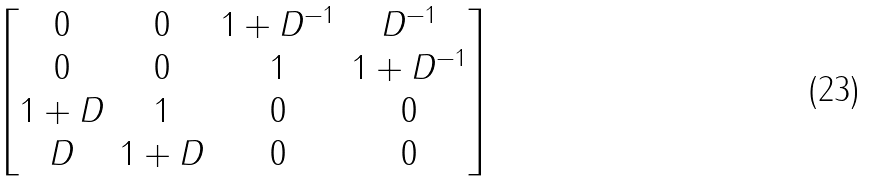<formula> <loc_0><loc_0><loc_500><loc_500>\begin{bmatrix} 0 & 0 & 1 + D ^ { - 1 } & D ^ { - 1 } \\ 0 & 0 & 1 & 1 + D ^ { - 1 } \\ 1 + D & 1 & 0 & 0 \\ D & 1 + D & 0 & 0 \end{bmatrix}</formula> 